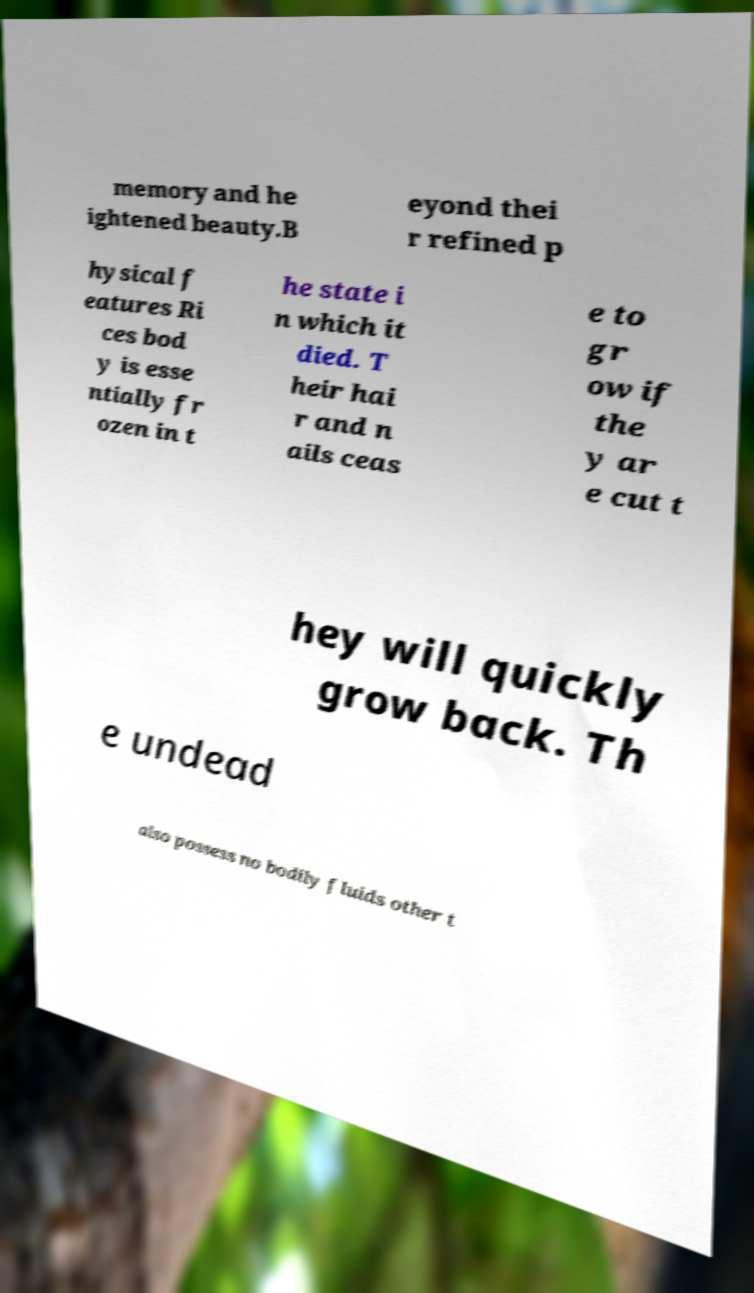For documentation purposes, I need the text within this image transcribed. Could you provide that? memory and he ightened beauty.B eyond thei r refined p hysical f eatures Ri ces bod y is esse ntially fr ozen in t he state i n which it died. T heir hai r and n ails ceas e to gr ow if the y ar e cut t hey will quickly grow back. Th e undead also possess no bodily fluids other t 